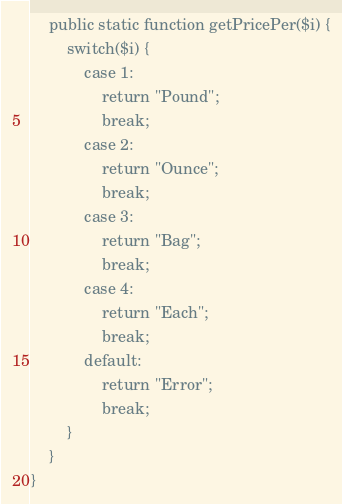Convert code to text. <code><loc_0><loc_0><loc_500><loc_500><_PHP_>
    public static function getPricePer($i) {
        switch($i) {
            case 1:
                return "Pound";
                break;
            case 2:
                return "Ounce";
                break;
            case 3:
                return "Bag";
                break;
            case 4:
                return "Each";
                break;
            default:
                return "Error";
                break;
        }
    }
}
</code> 